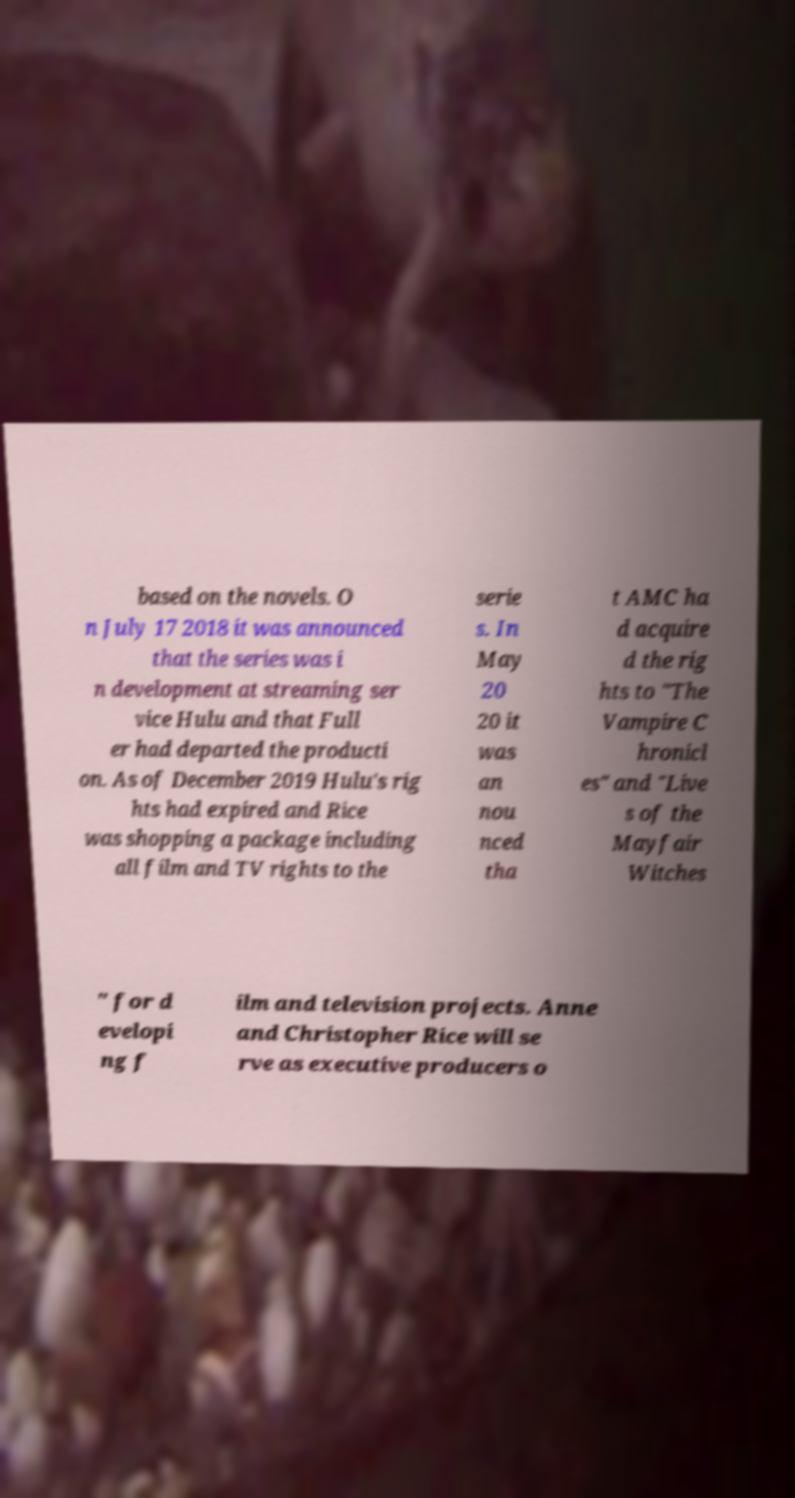Could you extract and type out the text from this image? based on the novels. O n July 17 2018 it was announced that the series was i n development at streaming ser vice Hulu and that Full er had departed the producti on. As of December 2019 Hulu's rig hts had expired and Rice was shopping a package including all film and TV rights to the serie s. In May 20 20 it was an nou nced tha t AMC ha d acquire d the rig hts to "The Vampire C hronicl es" and "Live s of the Mayfair Witches " for d evelopi ng f ilm and television projects. Anne and Christopher Rice will se rve as executive producers o 